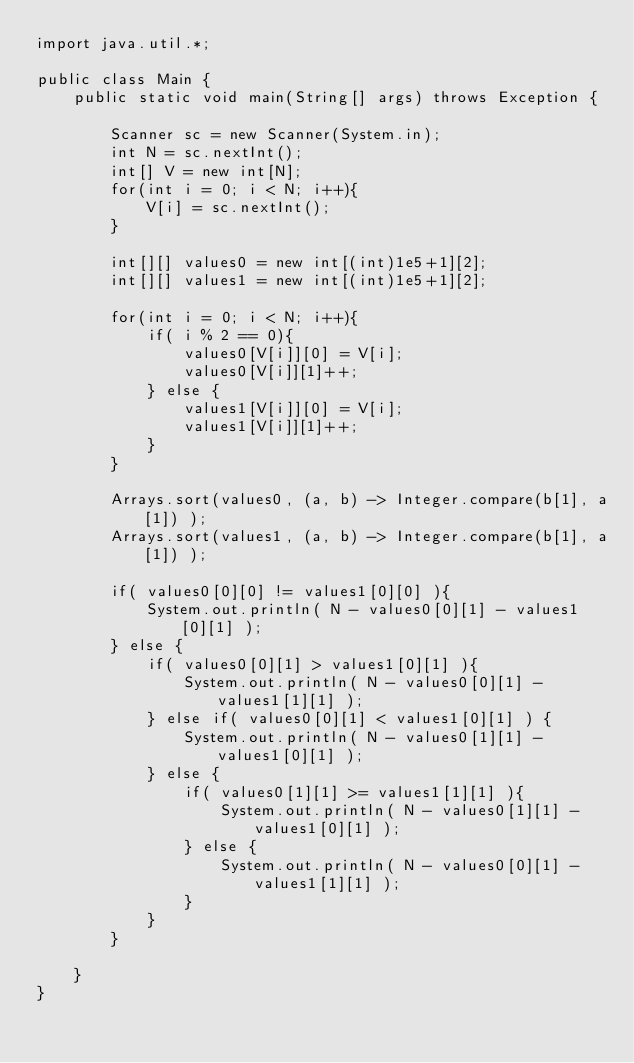<code> <loc_0><loc_0><loc_500><loc_500><_Java_>import java.util.*;

public class Main {
    public static void main(String[] args) throws Exception {

        Scanner sc = new Scanner(System.in);
        int N = sc.nextInt();
        int[] V = new int[N];
        for(int i = 0; i < N; i++){
            V[i] = sc.nextInt();
        }
        
        int[][] values0 = new int[(int)1e5+1][2];
        int[][] values1 = new int[(int)1e5+1][2];        
        
        for(int i = 0; i < N; i++){
            if( i % 2 == 0){
                values0[V[i]][0] = V[i];
                values0[V[i]][1]++;
            } else {
                values1[V[i]][0] = V[i];
                values1[V[i]][1]++;
            }
        }
        
        Arrays.sort(values0, (a, b) -> Integer.compare(b[1], a[1]) );
        Arrays.sort(values1, (a, b) -> Integer.compare(b[1], a[1]) ); 
        
        if( values0[0][0] != values1[0][0] ){
            System.out.println( N - values0[0][1] - values1[0][1] );
        } else {
            if( values0[0][1] > values1[0][1] ){
                System.out.println( N - values0[0][1] - values1[1][1] );
            } else if( values0[0][1] < values1[0][1] ) {
                System.out.println( N - values0[1][1] - values1[0][1] );
            } else {
                if( values0[1][1] >= values1[1][1] ){
                    System.out.println( N - values0[1][1] - values1[0][1] );
                } else {
                    System.out.println( N - values0[0][1] - values1[1][1] );
                }
            }
        }
        
    }
}
</code> 